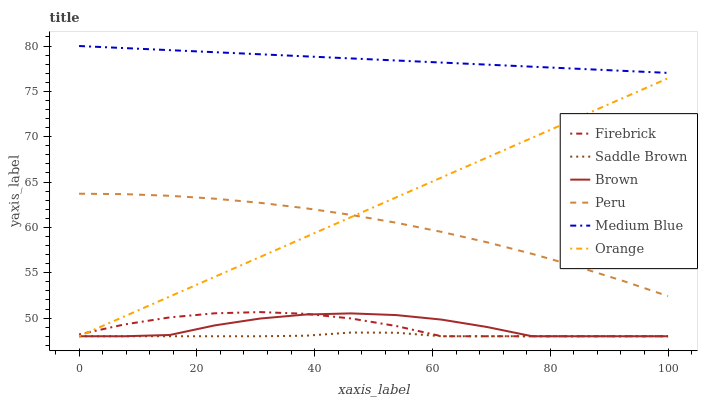Does Saddle Brown have the minimum area under the curve?
Answer yes or no. Yes. Does Medium Blue have the maximum area under the curve?
Answer yes or no. Yes. Does Firebrick have the minimum area under the curve?
Answer yes or no. No. Does Firebrick have the maximum area under the curve?
Answer yes or no. No. Is Orange the smoothest?
Answer yes or no. Yes. Is Brown the roughest?
Answer yes or no. Yes. Is Firebrick the smoothest?
Answer yes or no. No. Is Firebrick the roughest?
Answer yes or no. No. Does Brown have the lowest value?
Answer yes or no. Yes. Does Medium Blue have the lowest value?
Answer yes or no. No. Does Medium Blue have the highest value?
Answer yes or no. Yes. Does Firebrick have the highest value?
Answer yes or no. No. Is Saddle Brown less than Medium Blue?
Answer yes or no. Yes. Is Peru greater than Firebrick?
Answer yes or no. Yes. Does Orange intersect Brown?
Answer yes or no. Yes. Is Orange less than Brown?
Answer yes or no. No. Is Orange greater than Brown?
Answer yes or no. No. Does Saddle Brown intersect Medium Blue?
Answer yes or no. No. 